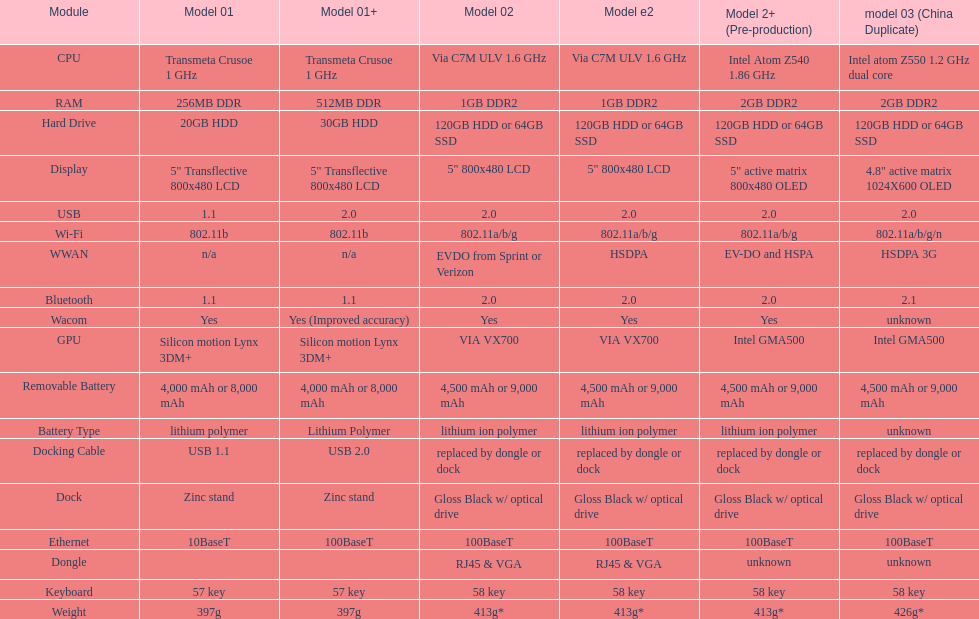Are there at least 13 different components on the chart? Yes. 